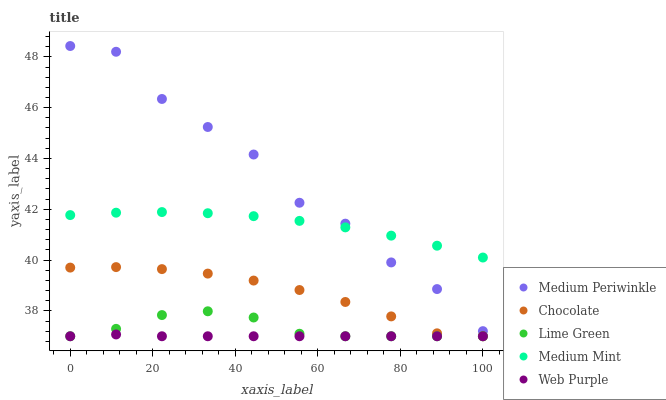Does Web Purple have the minimum area under the curve?
Answer yes or no. Yes. Does Medium Periwinkle have the maximum area under the curve?
Answer yes or no. Yes. Does Lime Green have the minimum area under the curve?
Answer yes or no. No. Does Lime Green have the maximum area under the curve?
Answer yes or no. No. Is Web Purple the smoothest?
Answer yes or no. Yes. Is Medium Periwinkle the roughest?
Answer yes or no. Yes. Is Lime Green the smoothest?
Answer yes or no. No. Is Lime Green the roughest?
Answer yes or no. No. Does Lime Green have the lowest value?
Answer yes or no. Yes. Does Medium Periwinkle have the lowest value?
Answer yes or no. No. Does Medium Periwinkle have the highest value?
Answer yes or no. Yes. Does Lime Green have the highest value?
Answer yes or no. No. Is Web Purple less than Medium Periwinkle?
Answer yes or no. Yes. Is Medium Periwinkle greater than Lime Green?
Answer yes or no. Yes. Does Medium Periwinkle intersect Medium Mint?
Answer yes or no. Yes. Is Medium Periwinkle less than Medium Mint?
Answer yes or no. No. Is Medium Periwinkle greater than Medium Mint?
Answer yes or no. No. Does Web Purple intersect Medium Periwinkle?
Answer yes or no. No. 